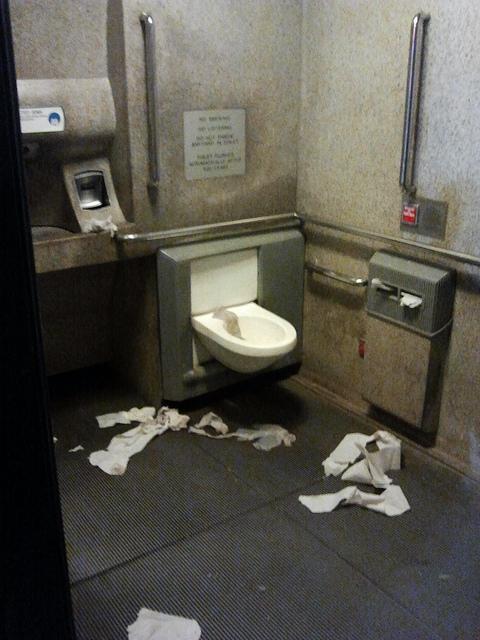Is the toilet clean?
Give a very brief answer. No. Is this a dirty bathroom?
Give a very brief answer. Yes. What is on the floor?
Concise answer only. Toilet paper. 